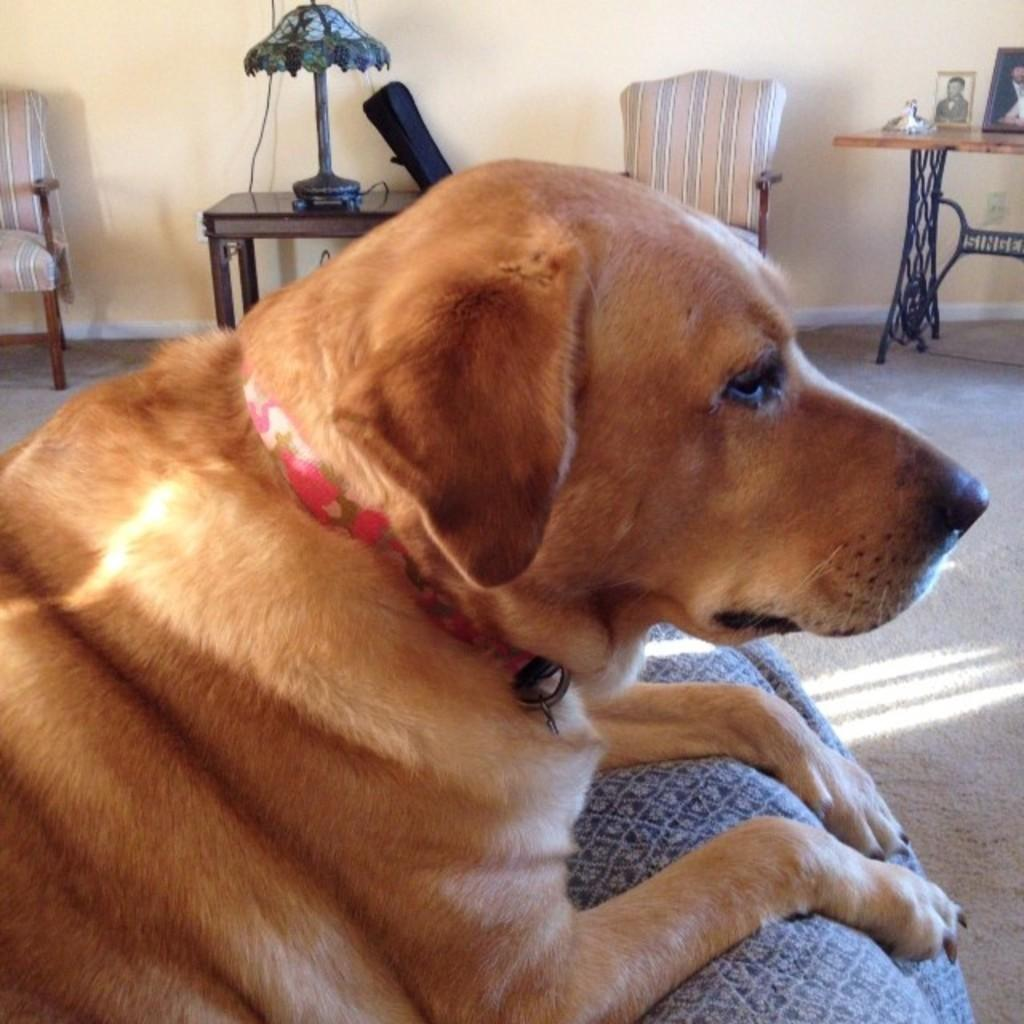What type of animal is in the image? There is a dog in the image. Where is the dog located? The dog is on a couch. What furniture can be seen in the background of the image? There are chairs and a table in the background of the image. What type of lighting is present in the background of the image? There is a lamp in the background of the image. What items are on the table in the background of the image? There are photo frames on the table in the background of the image. What type of business is being conducted in the image? There is no indication of any business being conducted in the image; it primarily features a dog on a couch and other furniture in the background. 